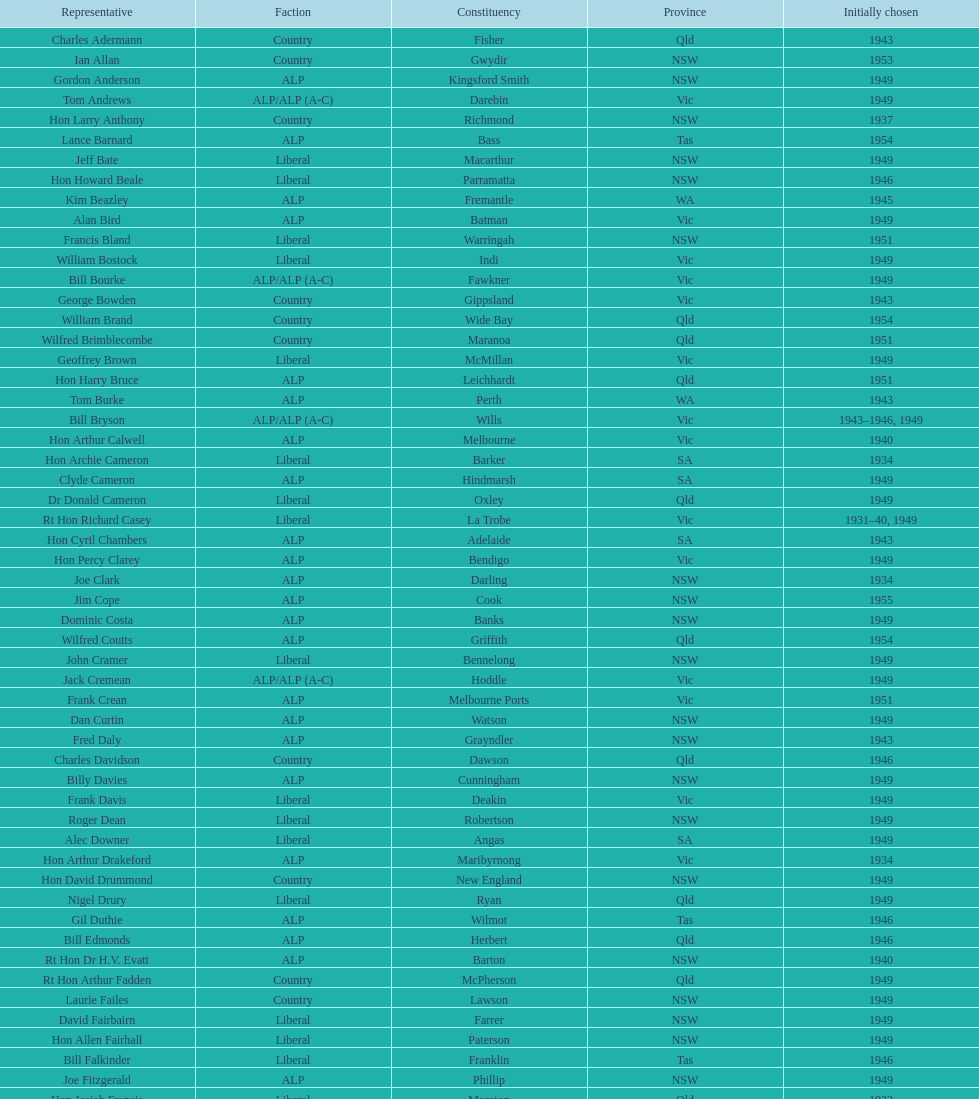After tom burke was elected, what was the next year where another tom would be elected? 1937. Could you parse the entire table? {'header': ['Representative', 'Faction', 'Constituency', 'Province', 'Initially chosen'], 'rows': [['Charles Adermann', 'Country', 'Fisher', 'Qld', '1943'], ['Ian Allan', 'Country', 'Gwydir', 'NSW', '1953'], ['Gordon Anderson', 'ALP', 'Kingsford Smith', 'NSW', '1949'], ['Tom Andrews', 'ALP/ALP (A-C)', 'Darebin', 'Vic', '1949'], ['Hon Larry Anthony', 'Country', 'Richmond', 'NSW', '1937'], ['Lance Barnard', 'ALP', 'Bass', 'Tas', '1954'], ['Jeff Bate', 'Liberal', 'Macarthur', 'NSW', '1949'], ['Hon Howard Beale', 'Liberal', 'Parramatta', 'NSW', '1946'], ['Kim Beazley', 'ALP', 'Fremantle', 'WA', '1945'], ['Alan Bird', 'ALP', 'Batman', 'Vic', '1949'], ['Francis Bland', 'Liberal', 'Warringah', 'NSW', '1951'], ['William Bostock', 'Liberal', 'Indi', 'Vic', '1949'], ['Bill Bourke', 'ALP/ALP (A-C)', 'Fawkner', 'Vic', '1949'], ['George Bowden', 'Country', 'Gippsland', 'Vic', '1943'], ['William Brand', 'Country', 'Wide Bay', 'Qld', '1954'], ['Wilfred Brimblecombe', 'Country', 'Maranoa', 'Qld', '1951'], ['Geoffrey Brown', 'Liberal', 'McMillan', 'Vic', '1949'], ['Hon Harry Bruce', 'ALP', 'Leichhardt', 'Qld', '1951'], ['Tom Burke', 'ALP', 'Perth', 'WA', '1943'], ['Bill Bryson', 'ALP/ALP (A-C)', 'Wills', 'Vic', '1943–1946, 1949'], ['Hon Arthur Calwell', 'ALP', 'Melbourne', 'Vic', '1940'], ['Hon Archie Cameron', 'Liberal', 'Barker', 'SA', '1934'], ['Clyde Cameron', 'ALP', 'Hindmarsh', 'SA', '1949'], ['Dr Donald Cameron', 'Liberal', 'Oxley', 'Qld', '1949'], ['Rt Hon Richard Casey', 'Liberal', 'La Trobe', 'Vic', '1931–40, 1949'], ['Hon Cyril Chambers', 'ALP', 'Adelaide', 'SA', '1943'], ['Hon Percy Clarey', 'ALP', 'Bendigo', 'Vic', '1949'], ['Joe Clark', 'ALP', 'Darling', 'NSW', '1934'], ['Jim Cope', 'ALP', 'Cook', 'NSW', '1955'], ['Dominic Costa', 'ALP', 'Banks', 'NSW', '1949'], ['Wilfred Coutts', 'ALP', 'Griffith', 'Qld', '1954'], ['John Cramer', 'Liberal', 'Bennelong', 'NSW', '1949'], ['Jack Cremean', 'ALP/ALP (A-C)', 'Hoddle', 'Vic', '1949'], ['Frank Crean', 'ALP', 'Melbourne Ports', 'Vic', '1951'], ['Dan Curtin', 'ALP', 'Watson', 'NSW', '1949'], ['Fred Daly', 'ALP', 'Grayndler', 'NSW', '1943'], ['Charles Davidson', 'Country', 'Dawson', 'Qld', '1946'], ['Billy Davies', 'ALP', 'Cunningham', 'NSW', '1949'], ['Frank Davis', 'Liberal', 'Deakin', 'Vic', '1949'], ['Roger Dean', 'Liberal', 'Robertson', 'NSW', '1949'], ['Alec Downer', 'Liberal', 'Angas', 'SA', '1949'], ['Hon Arthur Drakeford', 'ALP', 'Maribyrnong', 'Vic', '1934'], ['Hon David Drummond', 'Country', 'New England', 'NSW', '1949'], ['Nigel Drury', 'Liberal', 'Ryan', 'Qld', '1949'], ['Gil Duthie', 'ALP', 'Wilmot', 'Tas', '1946'], ['Bill Edmonds', 'ALP', 'Herbert', 'Qld', '1946'], ['Rt Hon Dr H.V. Evatt', 'ALP', 'Barton', 'NSW', '1940'], ['Rt Hon Arthur Fadden', 'Country', 'McPherson', 'Qld', '1949'], ['Laurie Failes', 'Country', 'Lawson', 'NSW', '1949'], ['David Fairbairn', 'Liberal', 'Farrer', 'NSW', '1949'], ['Hon Allen Fairhall', 'Liberal', 'Paterson', 'NSW', '1949'], ['Bill Falkinder', 'Liberal', 'Franklin', 'Tas', '1946'], ['Joe Fitzgerald', 'ALP', 'Phillip', 'NSW', '1949'], ['Hon Josiah Francis', 'Liberal', 'Moreton', 'Qld', '1922'], ['Allan Fraser', 'ALP', 'Eden-Monaro', 'NSW', '1943'], ['Jim Fraser', 'ALP', 'Australian Capital Territory', 'ACT', '1951'], ['Gordon Freeth', 'Liberal', 'Forrest', 'WA', '1949'], ['Arthur Fuller', 'Country', 'Hume', 'NSW', '1943–49, 1951'], ['Pat Galvin', 'ALP', 'Kingston', 'SA', '1951'], ['Arthur Greenup', 'ALP', 'Dalley', 'NSW', '1953'], ['Charles Griffiths', 'ALP', 'Shortland', 'NSW', '1949'], ['Jo Gullett', 'Liberal', 'Henty', 'Vic', '1946'], ['Len Hamilton', 'Country', 'Canning', 'WA', '1946'], ['Rt Hon Eric Harrison', 'Liberal', 'Wentworth', 'NSW', '1931'], ['Jim Harrison', 'ALP', 'Blaxland', 'NSW', '1949'], ['Hon Paul Hasluck', 'Liberal', 'Curtin', 'WA', '1949'], ['Hon William Haworth', 'Liberal', 'Isaacs', 'Vic', '1949'], ['Leslie Haylen', 'ALP', 'Parkes', 'NSW', '1943'], ['Rt Hon Harold Holt', 'Liberal', 'Higgins', 'Vic', '1935'], ['John Howse', 'Liberal', 'Calare', 'NSW', '1946'], ['Alan Hulme', 'Liberal', 'Petrie', 'Qld', '1949'], ['William Jack', 'Liberal', 'North Sydney', 'NSW', '1949'], ['Rowley James', 'ALP', 'Hunter', 'NSW', '1928'], ['Hon Herbert Johnson', 'ALP', 'Kalgoorlie', 'WA', '1940'], ['Bob Joshua', 'ALP/ALP (A-C)', 'Ballaarat', 'ALP', '1951'], ['Percy Joske', 'Liberal', 'Balaclava', 'Vic', '1951'], ['Hon Wilfrid Kent Hughes', 'Liberal', 'Chisholm', 'Vic', '1949'], ['Stan Keon', 'ALP/ALP (A-C)', 'Yarra', 'Vic', '1949'], ['William Lawrence', 'Liberal', 'Wimmera', 'Vic', '1949'], ['Hon George Lawson', 'ALP', 'Brisbane', 'Qld', '1931'], ['Nelson Lemmon', 'ALP', 'St George', 'NSW', '1943–49, 1954'], ['Hugh Leslie', 'Liberal', 'Moore', 'Country', '1949'], ['Robert Lindsay', 'Liberal', 'Flinders', 'Vic', '1954'], ['Tony Luchetti', 'ALP', 'Macquarie', 'NSW', '1951'], ['Aubrey Luck', 'Liberal', 'Darwin', 'Tas', '1951'], ['Philip Lucock', 'Country', 'Lyne', 'NSW', '1953'], ['Dan Mackinnon', 'Liberal', 'Corangamite', 'Vic', '1949–51, 1953'], ['Hon Norman Makin', 'ALP', 'Sturt', 'SA', '1919–46, 1954'], ['Hon Philip McBride', 'Liberal', 'Wakefield', 'SA', '1931–37, 1937–43 (S), 1946'], ['Malcolm McColm', 'Liberal', 'Bowman', 'Qld', '1949'], ['Rt Hon John McEwen', 'Country', 'Murray', 'Vic', '1934'], ['John McLeay', 'Liberal', 'Boothby', 'SA', '1949'], ['Don McLeod', 'Liberal', 'Wannon', 'ALP', '1940–49, 1951'], ['Hon William McMahon', 'Liberal', 'Lowe', 'NSW', '1949'], ['Rt Hon Robert Menzies', 'Liberal', 'Kooyong', 'Vic', '1934'], ['Dan Minogue', 'ALP', 'West Sydney', 'NSW', '1949'], ['Charles Morgan', 'ALP', 'Reid', 'NSW', '1940–46, 1949'], ['Jack Mullens', 'ALP/ALP (A-C)', 'Gellibrand', 'Vic', '1949'], ['Jock Nelson', 'ALP', 'Northern Territory', 'NT', '1949'], ["William O'Connor", 'ALP', 'Martin', 'NSW', '1946'], ['Hubert Opperman', 'Liberal', 'Corio', 'Vic', '1949'], ['Hon Frederick Osborne', 'Liberal', 'Evans', 'NSW', '1949'], ['Rt Hon Sir Earle Page', 'Country', 'Cowper', 'NSW', '1919'], ['Henry Pearce', 'Liberal', 'Capricornia', 'Qld', '1949'], ['Ted Peters', 'ALP', 'Burke', 'Vic', '1949'], ['Hon Reg Pollard', 'ALP', 'Lalor', 'Vic', '1937'], ['Hon Bill Riordan', 'ALP', 'Kennedy', 'Qld', '1936'], ['Hugh Roberton', 'Country', 'Riverina', 'NSW', '1949'], ['Edgar Russell', 'ALP', 'Grey', 'SA', '1943'], ['Tom Sheehan', 'ALP', 'Cook', 'NSW', '1937'], ['Frank Stewart', 'ALP', 'Lang', 'NSW', '1953'], ['Reginald Swartz', 'Liberal', 'Darling Downs', 'Qld', '1949'], ['Albert Thompson', 'ALP', 'Port Adelaide', 'SA', '1946'], ['Frank Timson', 'Liberal', 'Higinbotham', 'Vic', '1949'], ['Hon Athol Townley', 'Liberal', 'Denison', 'Tas', '1949'], ['Winton Turnbull', 'Country', 'Mallee', 'Vic', '1946'], ['Harry Turner', 'Liberal', 'Bradfield', 'NSW', '1952'], ['Hon Eddie Ward', 'ALP', 'East Sydney', 'NSW', '1931, 1932'], ['David Oliver Watkins', 'ALP', 'Newcastle', 'NSW', '1935'], ['Harry Webb', 'ALP', 'Swan', 'WA', '1954'], ['William Wentworth', 'Liberal', 'Mackellar', 'NSW', '1949'], ['Roy Wheeler', 'Liberal', 'Mitchell', 'NSW', '1949'], ['Gough Whitlam', 'ALP', 'Werriwa', 'NSW', '1952'], ['Bruce Wight', 'Liberal', 'Lilley', 'Qld', '1949']]} 